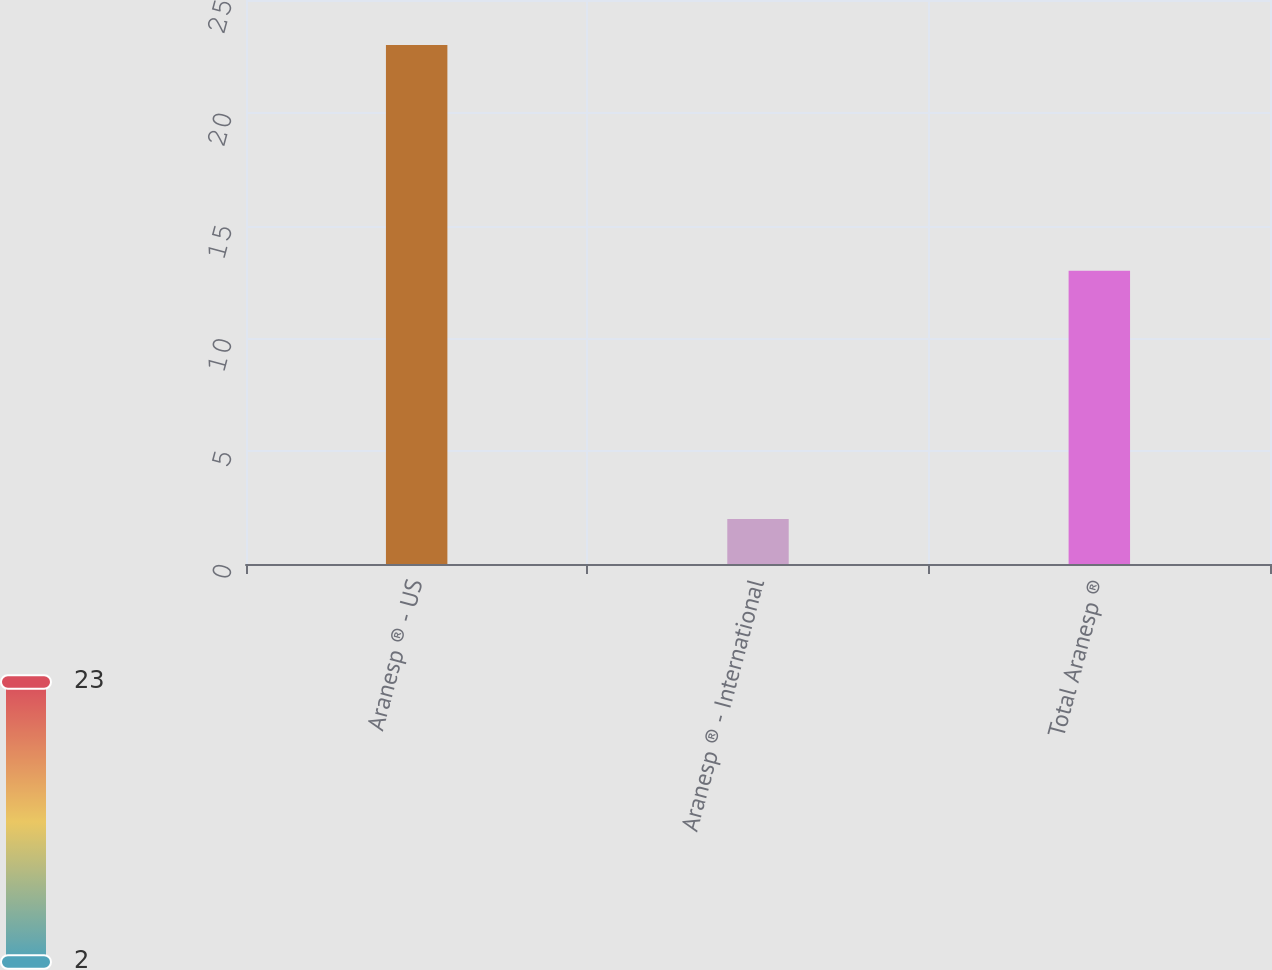<chart> <loc_0><loc_0><loc_500><loc_500><bar_chart><fcel>Aranesp ® - US<fcel>Aranesp ® - International<fcel>Total Aranesp ®<nl><fcel>23<fcel>2<fcel>13<nl></chart> 